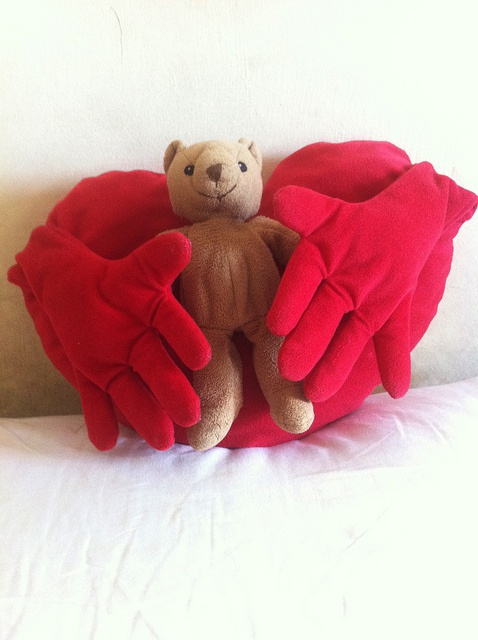Describe the objects in this image and their specific colors. I can see bed in ivory, white, lightpink, pink, and brown tones and teddy bear in ivory, maroon, and brown tones in this image. 